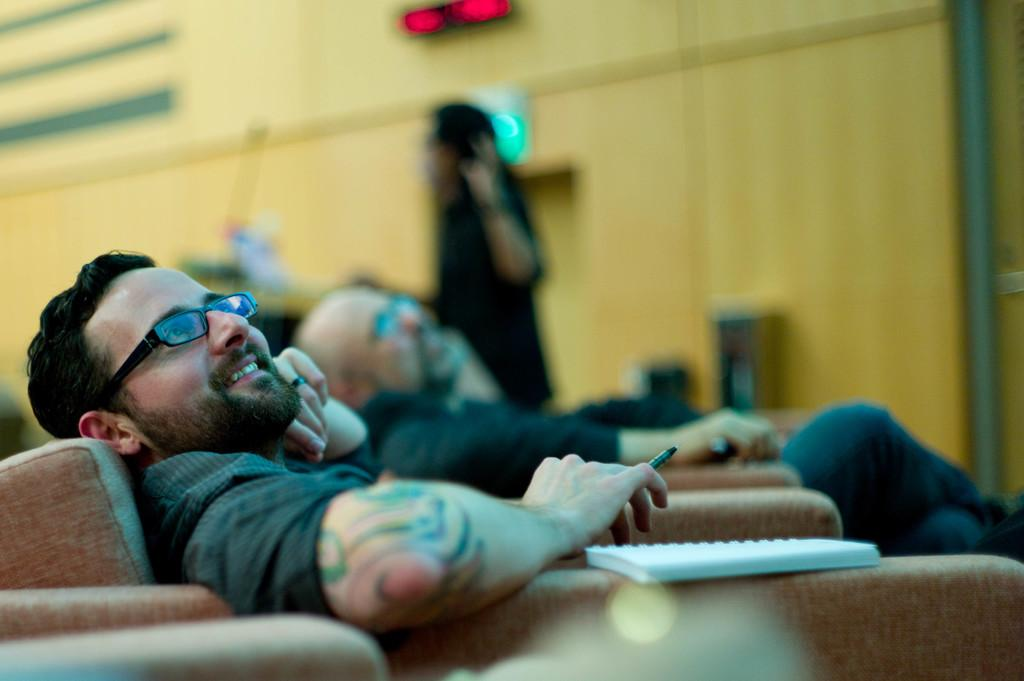What are the people in the image doing? The people in the image are sitting on chairs. Can you describe any objects on the chairs? Yes, there is a book on one of the chairs. What can be seen in the background of the image? There is a wall in the background of the image. Are there any people standing in the image? Yes, there is a person standing in the image. What type of road can be seen in the image? There is no road visible in the image. What kind of lunch is being served in the image? There is no lunch being served in the image. 